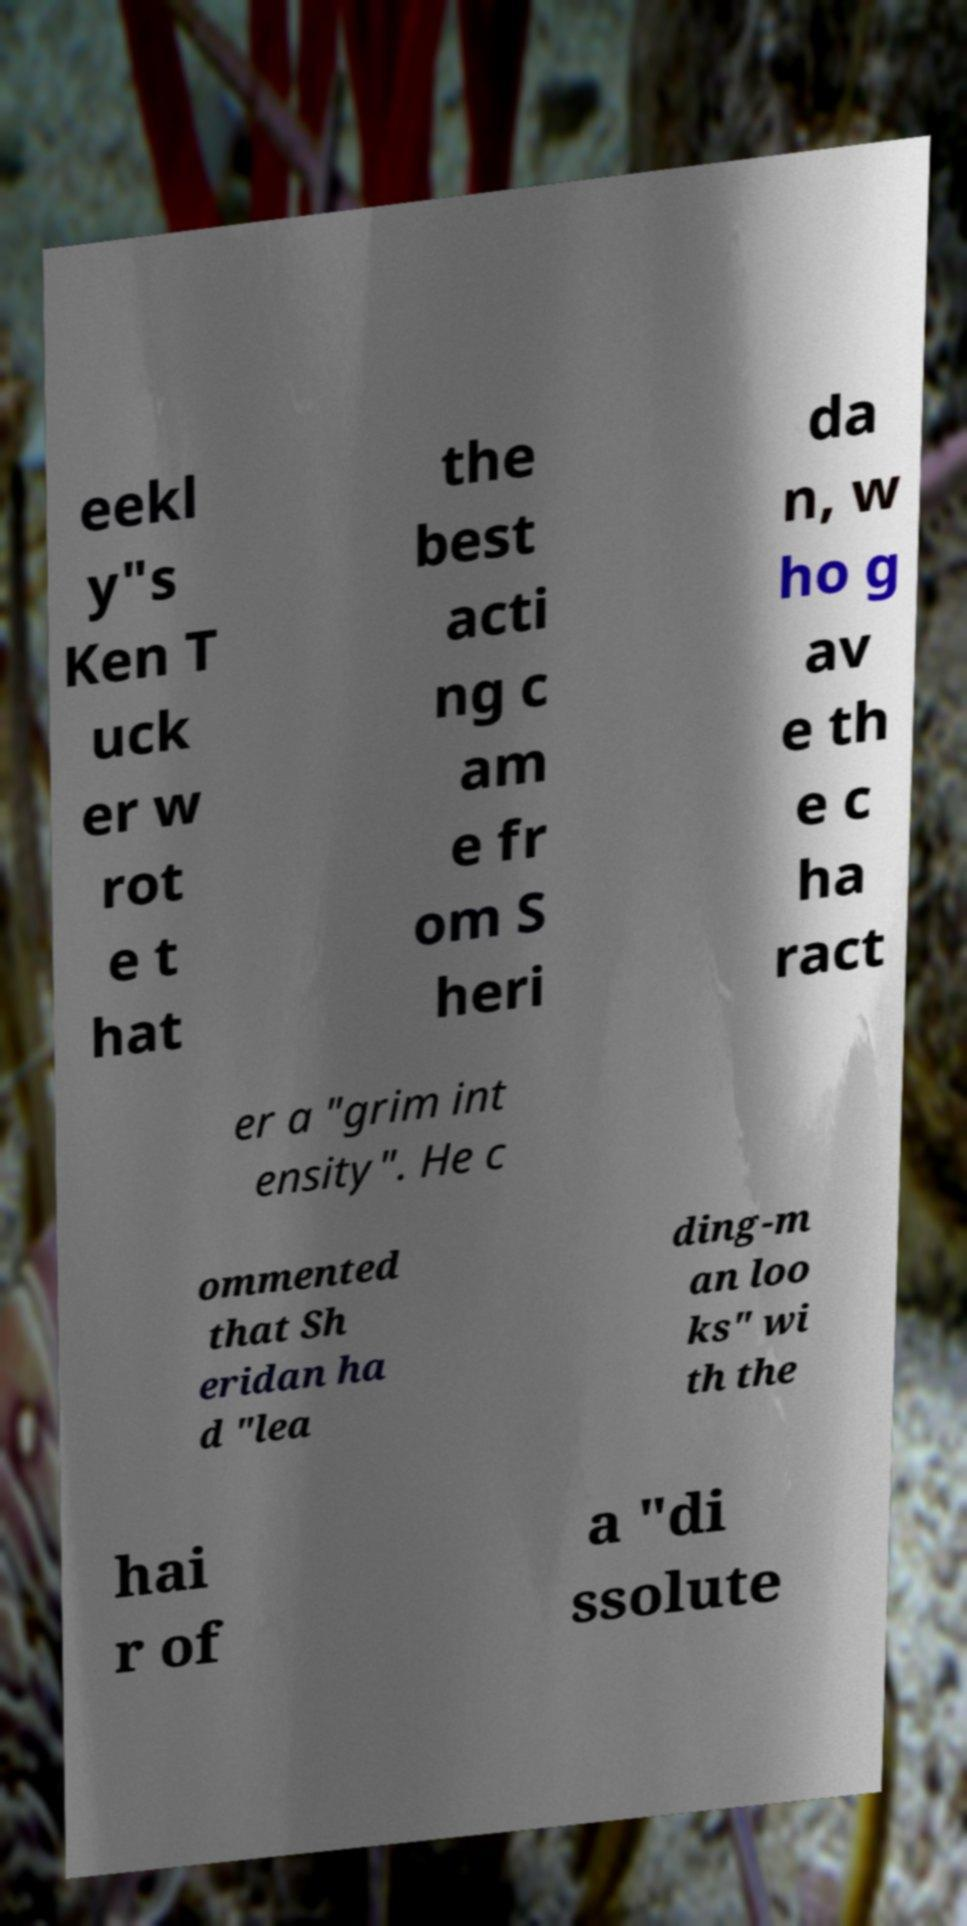Can you read and provide the text displayed in the image?This photo seems to have some interesting text. Can you extract and type it out for me? eekl y"s Ken T uck er w rot e t hat the best acti ng c am e fr om S heri da n, w ho g av e th e c ha ract er a "grim int ensity". He c ommented that Sh eridan ha d "lea ding-m an loo ks" wi th the hai r of a "di ssolute 